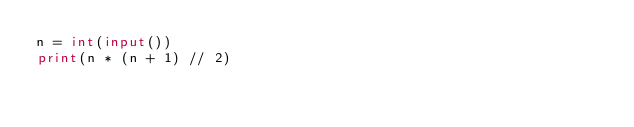Convert code to text. <code><loc_0><loc_0><loc_500><loc_500><_Python_>n = int(input())
print(n * (n + 1) // 2)
</code> 